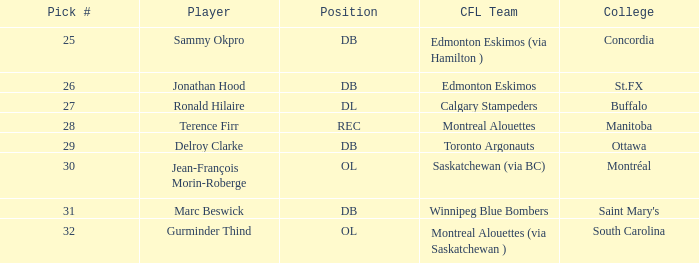Which College has a Position of ol, and a Pick # smaller than 32? Montréal. 